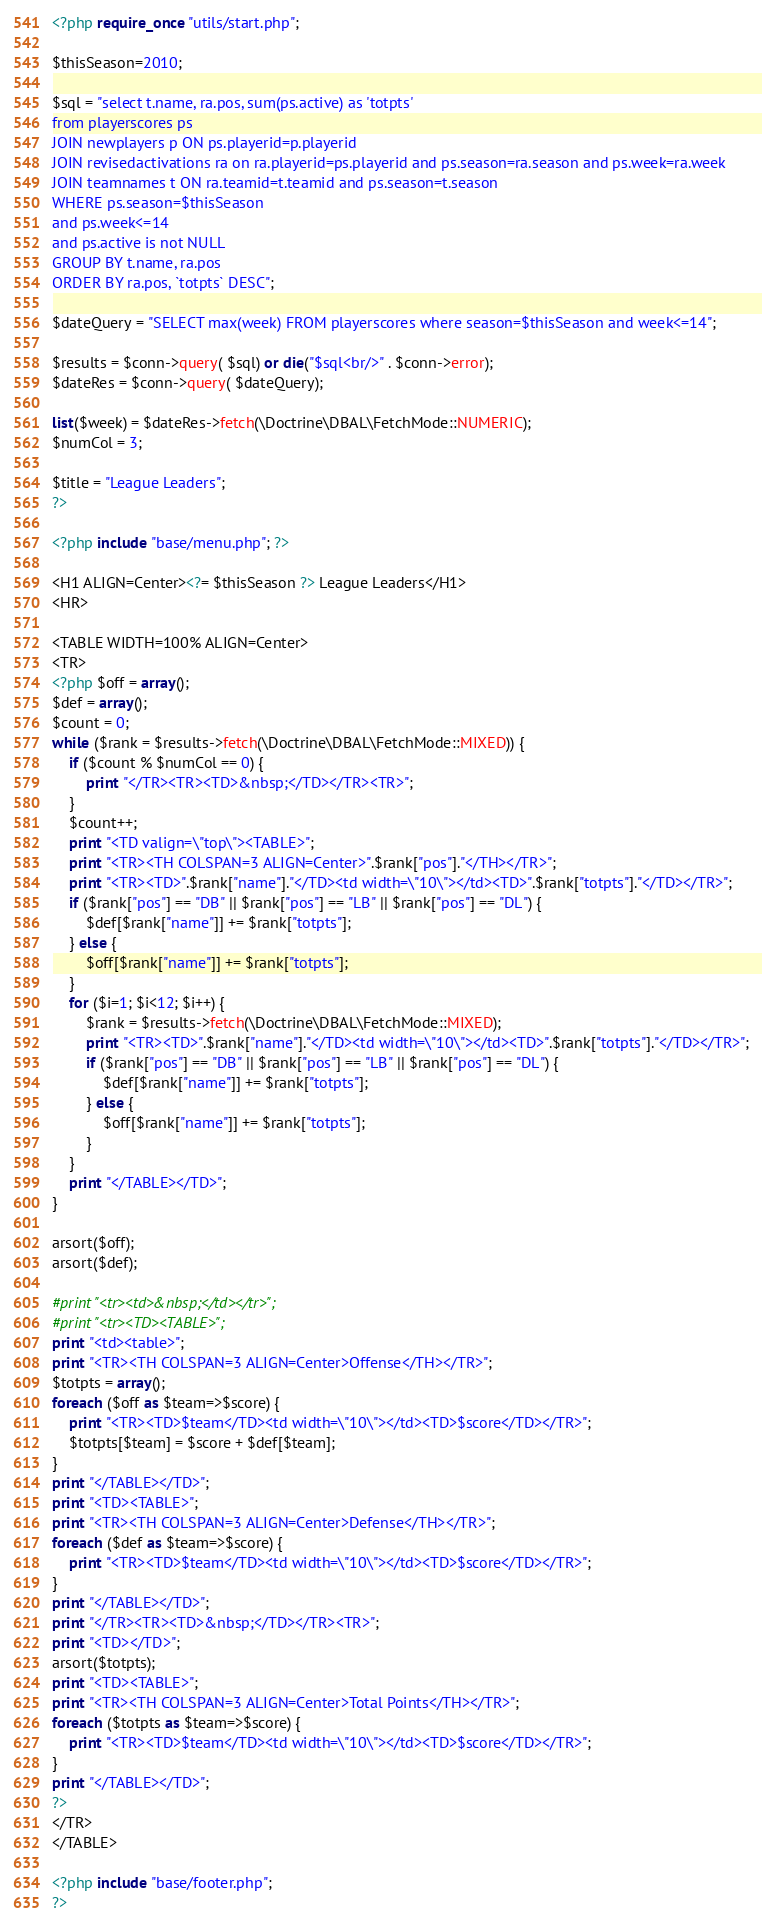Convert code to text. <code><loc_0><loc_0><loc_500><loc_500><_PHP_><?php require_once "utils/start.php";

$thisSeason=2010;

$sql = "select t.name, ra.pos, sum(ps.active) as 'totpts'
from playerscores ps
JOIN newplayers p ON ps.playerid=p.playerid
JOIN revisedactivations ra on ra.playerid=ps.playerid and ps.season=ra.season and ps.week=ra.week
JOIN teamnames t ON ra.teamid=t.teamid and ps.season=t.season
WHERE ps.season=$thisSeason
and ps.week<=14
and ps.active is not NULL
GROUP BY t.name, ra.pos
ORDER BY ra.pos, `totpts` DESC";

$dateQuery = "SELECT max(week) FROM playerscores where season=$thisSeason and week<=14";

$results = $conn->query( $sql) or die("$sql<br/>" . $conn->error);
$dateRes = $conn->query( $dateQuery);

list($week) = $dateRes->fetch(\Doctrine\DBAL\FetchMode::NUMERIC);
$numCol = 3;

$title = "League Leaders";
?>

<?php include "base/menu.php"; ?>

<H1 ALIGN=Center><?= $thisSeason ?> League Leaders</H1>
<HR>

<TABLE WIDTH=100% ALIGN=Center> 
<TR>
<?php $off = array();
$def = array();
$count = 0;
while ($rank = $results->fetch(\Doctrine\DBAL\FetchMode::MIXED)) {
	if ($count % $numCol == 0) {
		print "</TR><TR><TD>&nbsp;</TD></TR><TR>";
	}
	$count++;
	print "<TD valign=\"top\"><TABLE>";
	print "<TR><TH COLSPAN=3 ALIGN=Center>".$rank["pos"]."</TH></TR>";
	print "<TR><TD>".$rank["name"]."</TD><td width=\"10\"></td><TD>".$rank["totpts"]."</TD></TR>";
    if ($rank["pos"] == "DB" || $rank["pos"] == "LB" || $rank["pos"] == "DL") {
        $def[$rank["name"]] += $rank["totpts"];
    } else {
        $off[$rank["name"]] += $rank["totpts"];
    }
	for ($i=1; $i<12; $i++) {
        $rank = $results->fetch(\Doctrine\DBAL\FetchMode::MIXED);
		print "<TR><TD>".$rank["name"]."</TD><td width=\"10\"></td><TD>".$rank["totpts"]."</TD></TR>";
        if ($rank["pos"] == "DB" || $rank["pos"] == "LB" || $rank["pos"] == "DL") {
            $def[$rank["name"]] += $rank["totpts"];
        } else {
            $off[$rank["name"]] += $rank["totpts"];
        }
	}
	print "</TABLE></TD>";
}

arsort($off);
arsort($def);

#print "<tr><td>&nbsp;</td></tr>";
#print "<tr><TD><TABLE>";
print "<td><table>";
print "<TR><TH COLSPAN=3 ALIGN=Center>Offense</TH></TR>";
$totpts = array();
foreach ($off as $team=>$score) {
    print "<TR><TD>$team</TD><td width=\"10\"></td><TD>$score</TD></TR>";
    $totpts[$team] = $score + $def[$team];
}
print "</TABLE></TD>";
print "<TD><TABLE>";
print "<TR><TH COLSPAN=3 ALIGN=Center>Defense</TH></TR>";
foreach ($def as $team=>$score) {
    print "<TR><TD>$team</TD><td width=\"10\"></td><TD>$score</TD></TR>";
}
print "</TABLE></TD>";
print "</TR><TR><TD>&nbsp;</TD></TR><TR>";
print "<TD></TD>";
arsort($totpts);
print "<TD><TABLE>";
print "<TR><TH COLSPAN=3 ALIGN=Center>Total Points</TH></TR>";
foreach ($totpts as $team=>$score) {
    print "<TR><TD>$team</TD><td width=\"10\"></td><TD>$score</TD></TR>";
}
print "</TABLE></TD>";
?>
</TR>
</TABLE>

<?php include "base/footer.php";
?>
</code> 